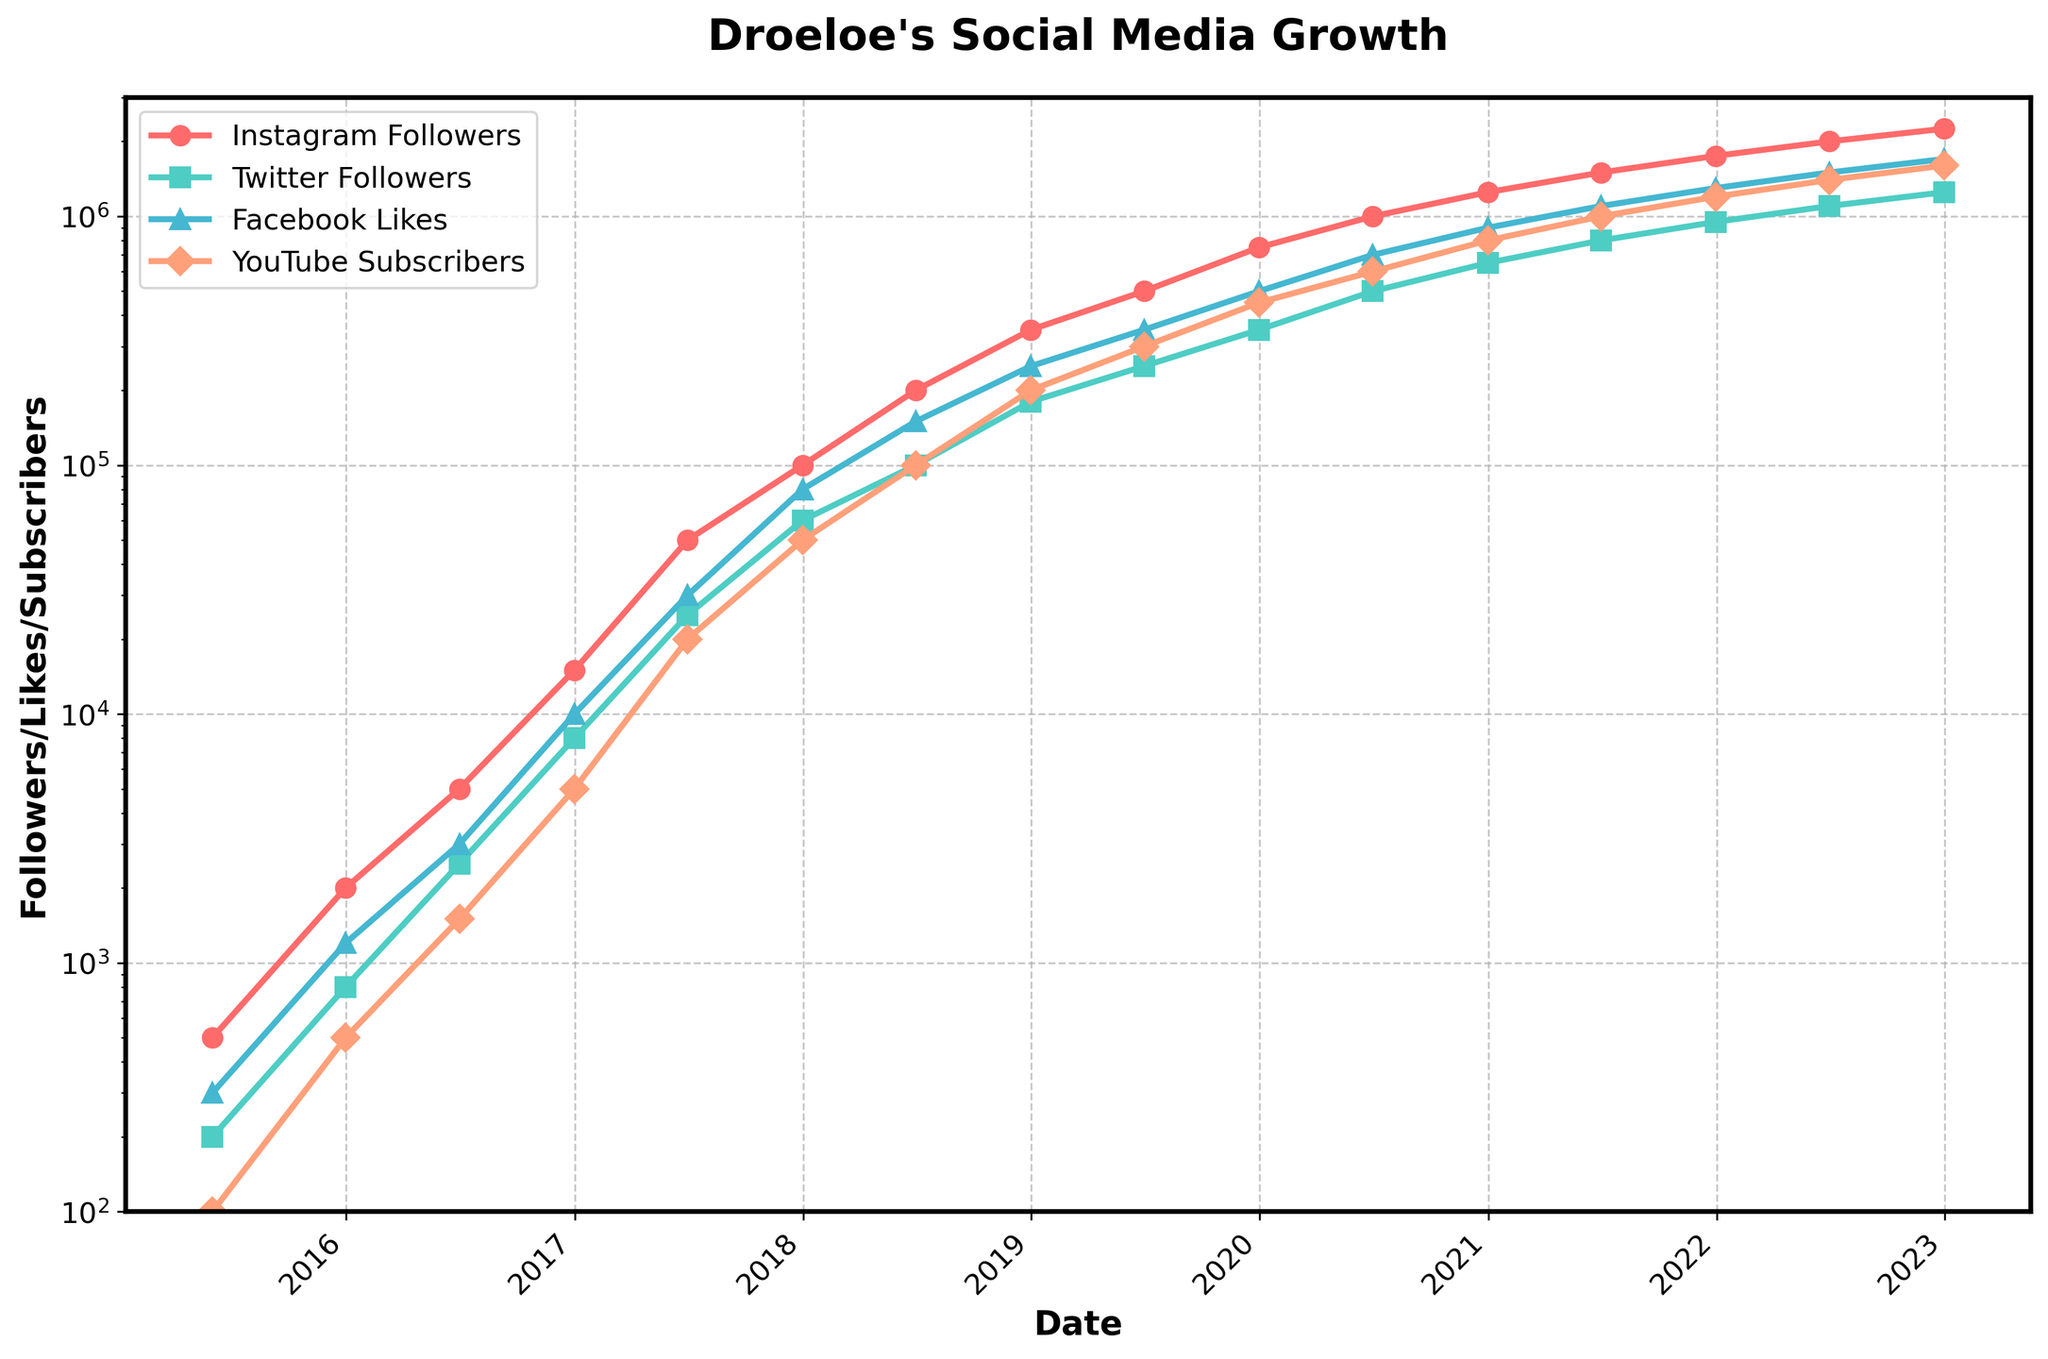What's the approximate number of Instagram followers Droeloe had by the end of 2017? Look at the data point corresponding to Instagram followers on the date 2017-12-31.
Answer: 100,000 Which social media platform had the least followers at the beginning of the observed period in mid-2015? Review the figures for all social media platforms on 2015-06-01 and identify the one with the smallest number.
Answer: YouTube Subscribers Between which two consecutive time points does the largest increase in Facebook Likes occur? Compare the differences in Facebook Likes between all adjacent data points and find the maximum difference.
Answer: 2019-12-31 to 2020-06-30 On which date does YouTube Subscribers reach 1,000,000? Locate the data point where YouTube Subscribers first equals or surpasses 1,000,000.
Answer: 2021-06-30 Which platform shows the most consistent growth pattern over the entire period? Compare the overall trends and slopes for each platform.
Answer: Instagram Followers How many times did Instagram Followers double within a year between mid-2015 and end-2022? Identify the instances where Instagram Followers' value roughly doubles from the previous year's data.
Answer: 4 times What is the average growth per year of Twitter Followers from mid-2015 to the end of 2022? Calculate the total growth in Twitter Followers over the period and divide by the number of years (7.5 years).
Answer: About 166,667 per year How do the YouTube subscribers compare to Twitter followers at the end of 2019? Examine the data for YouTube Subscribers and Twitter Followers on 2019-12-31 and compare the numbers.
Answer: YouTube Subscribers > Twitter Followers Which social media saw the slowest initial growth from 2015 to 2016? Analyze the growth between mid-2015 and the end of 2016 for each platform and identify the smallest increase.
Answer: Facebook Likes If you plot a general trend line for Facebook Likes over the entire period, in which year does it become twice that of YouTube Subscribers? Approximate the overall trend for Facebook Likes and YouTube Subscribers and find the year when Facebook Likes is roughly double YouTube Subscribers.
Answer: 2017 